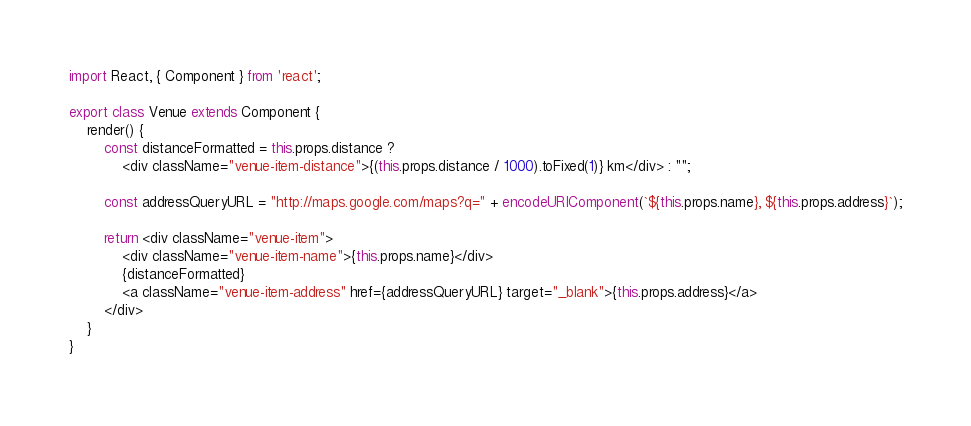Convert code to text. <code><loc_0><loc_0><loc_500><loc_500><_JavaScript_>import React, { Component } from 'react';

export class Venue extends Component {
	render() {
		const distanceFormatted = this.props.distance ?
			<div className="venue-item-distance">{(this.props.distance / 1000).toFixed(1)} km</div> : "";

		const addressQueryURL = "http://maps.google.com/maps?q=" + encodeURIComponent(`${this.props.name}, ${this.props.address}`);

		return <div className="venue-item">
			<div className="venue-item-name">{this.props.name}</div>
			{distanceFormatted}
			<a className="venue-item-address" href={addressQueryURL} target="_blank">{this.props.address}</a>
		</div>
	}
}</code> 